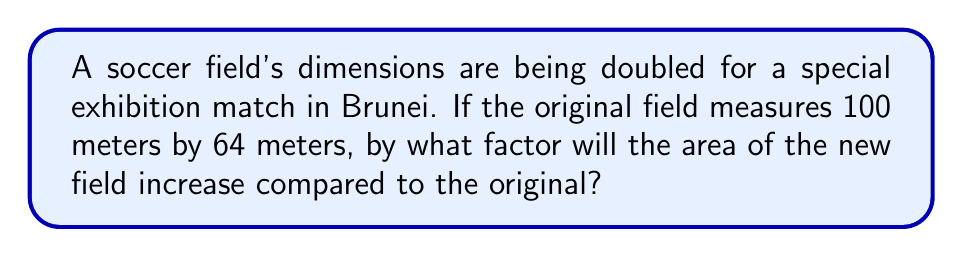Teach me how to tackle this problem. Let's approach this step-by-step:

1) First, let's calculate the area of the original field:
   Original Area = $100 \text{ m} \times 64 \text{ m} = 6400 \text{ m}^2$

2) Now, the dimensions are being doubled. This means:
   New length = $100 \text{ m} \times 2 = 200 \text{ m}$
   New width = $64 \text{ m} \times 2 = 128 \text{ m}$

3) Let's calculate the area of the new field:
   New Area = $200 \text{ m} \times 128 \text{ m} = 25600 \text{ m}^2$

4) To find the factor of increase, we divide the new area by the original area:
   
   Factor of increase = $\frac{\text{New Area}}{\text{Original Area}} = \frac{25600}{6400} = 4$

5) We can also think about this in terms of exponents:
   When we double each dimension, we're effectively squaring the increase:
   $2^2 = 4$

Thus, the area increases by a factor of 4, or we can say it increases to 4 times its original size.
Answer: $4$ 